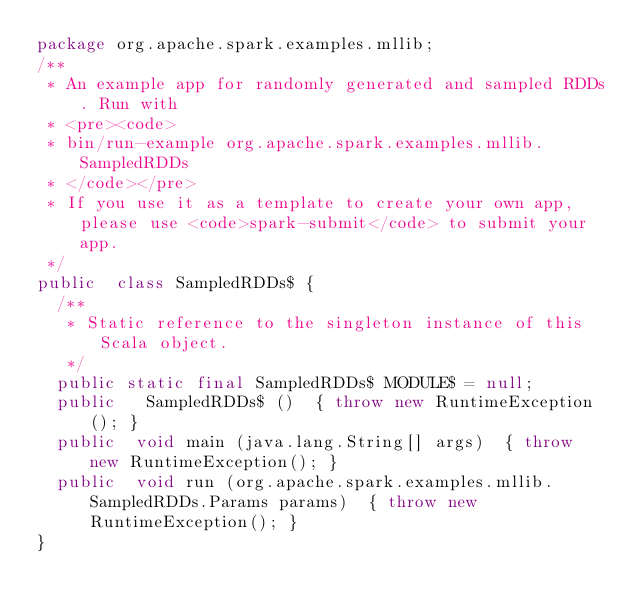<code> <loc_0><loc_0><loc_500><loc_500><_Java_>package org.apache.spark.examples.mllib;
/**
 * An example app for randomly generated and sampled RDDs. Run with
 * <pre><code>
 * bin/run-example org.apache.spark.examples.mllib.SampledRDDs
 * </code></pre>
 * If you use it as a template to create your own app, please use <code>spark-submit</code> to submit your app.
 */
public  class SampledRDDs$ {
  /**
   * Static reference to the singleton instance of this Scala object.
   */
  public static final SampledRDDs$ MODULE$ = null;
  public   SampledRDDs$ ()  { throw new RuntimeException(); }
  public  void main (java.lang.String[] args)  { throw new RuntimeException(); }
  public  void run (org.apache.spark.examples.mllib.SampledRDDs.Params params)  { throw new RuntimeException(); }
}
</code> 